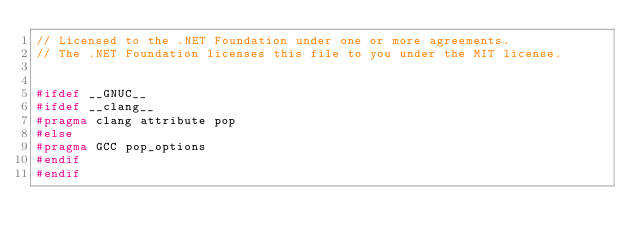Convert code to text. <code><loc_0><loc_0><loc_500><loc_500><_C_>// Licensed to the .NET Foundation under one or more agreements.
// The .NET Foundation licenses this file to you under the MIT license.


#ifdef __GNUC__
#ifdef __clang__
#pragma clang attribute pop
#else
#pragma GCC pop_options
#endif
#endif
</code> 